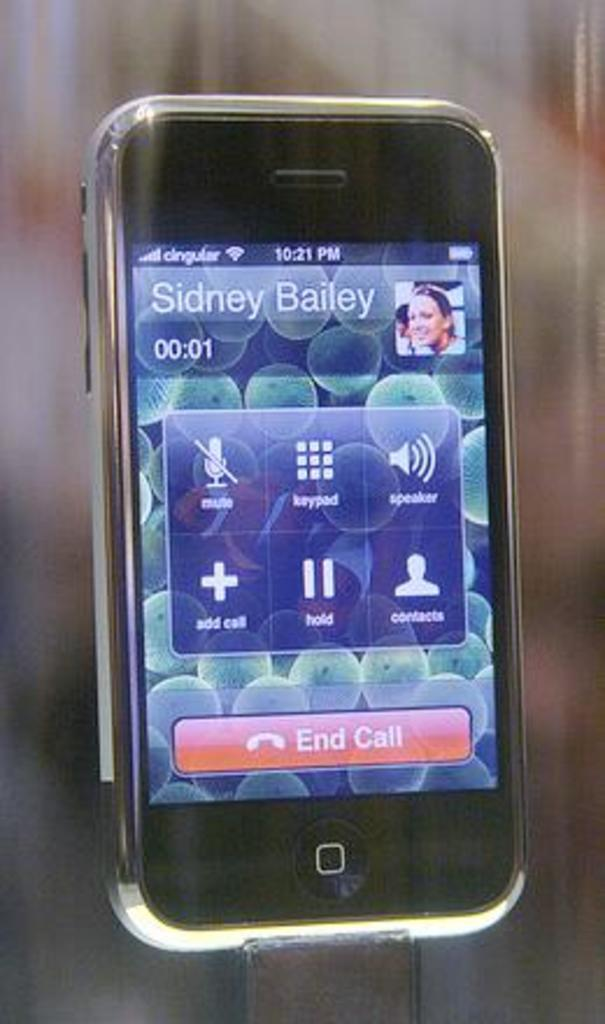<image>
Create a compact narrative representing the image presented. Sidney Bailey is currently on the phone, and the call has lasted one second so far. 